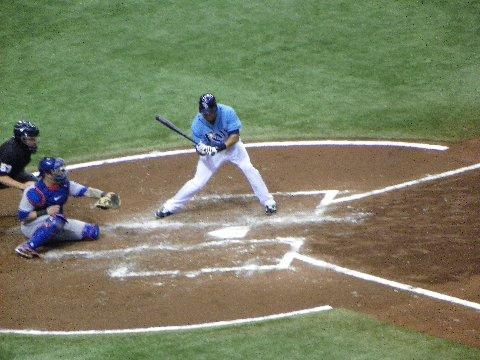Is this a little league game?
Short answer required. No. Are the Reds playing an away game?
Answer briefly. No. What positions are these players?
Keep it brief. Batter and catcher. What sport is being played?
Answer briefly. Baseball. 